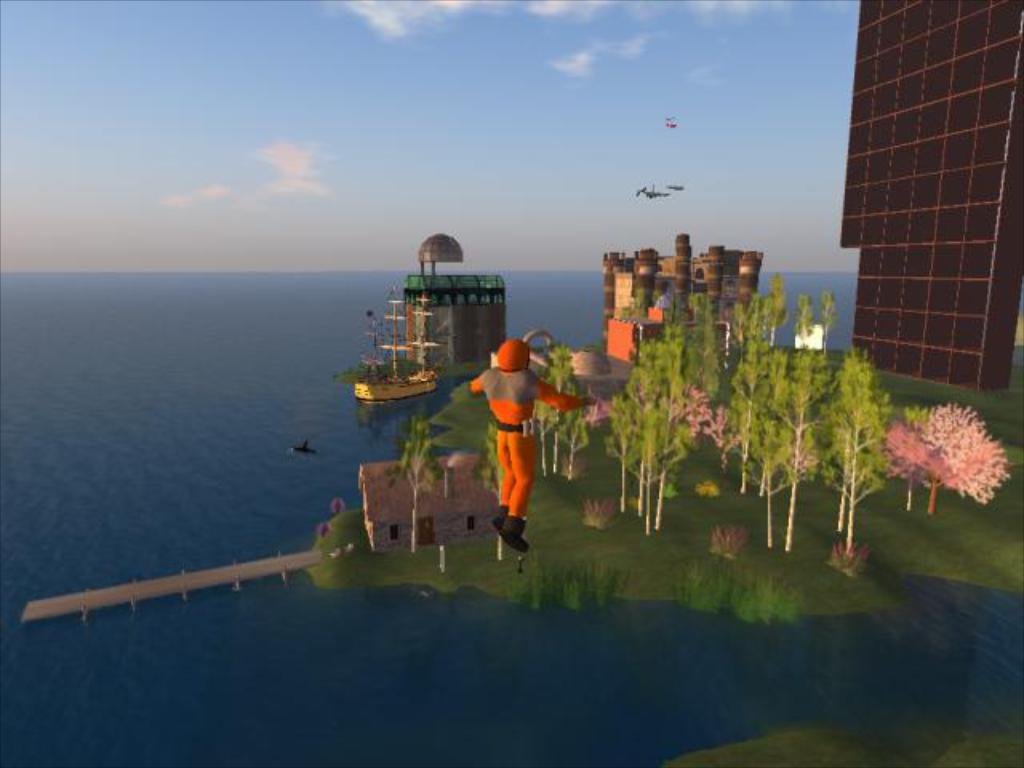Could you give a brief overview of what you see in this image? In this picture I can observe a graphic. There is a man wearing an orange color dress. I can observe some trees and a building on the right side. In the background there is an ocean and some clouds in the sky. 